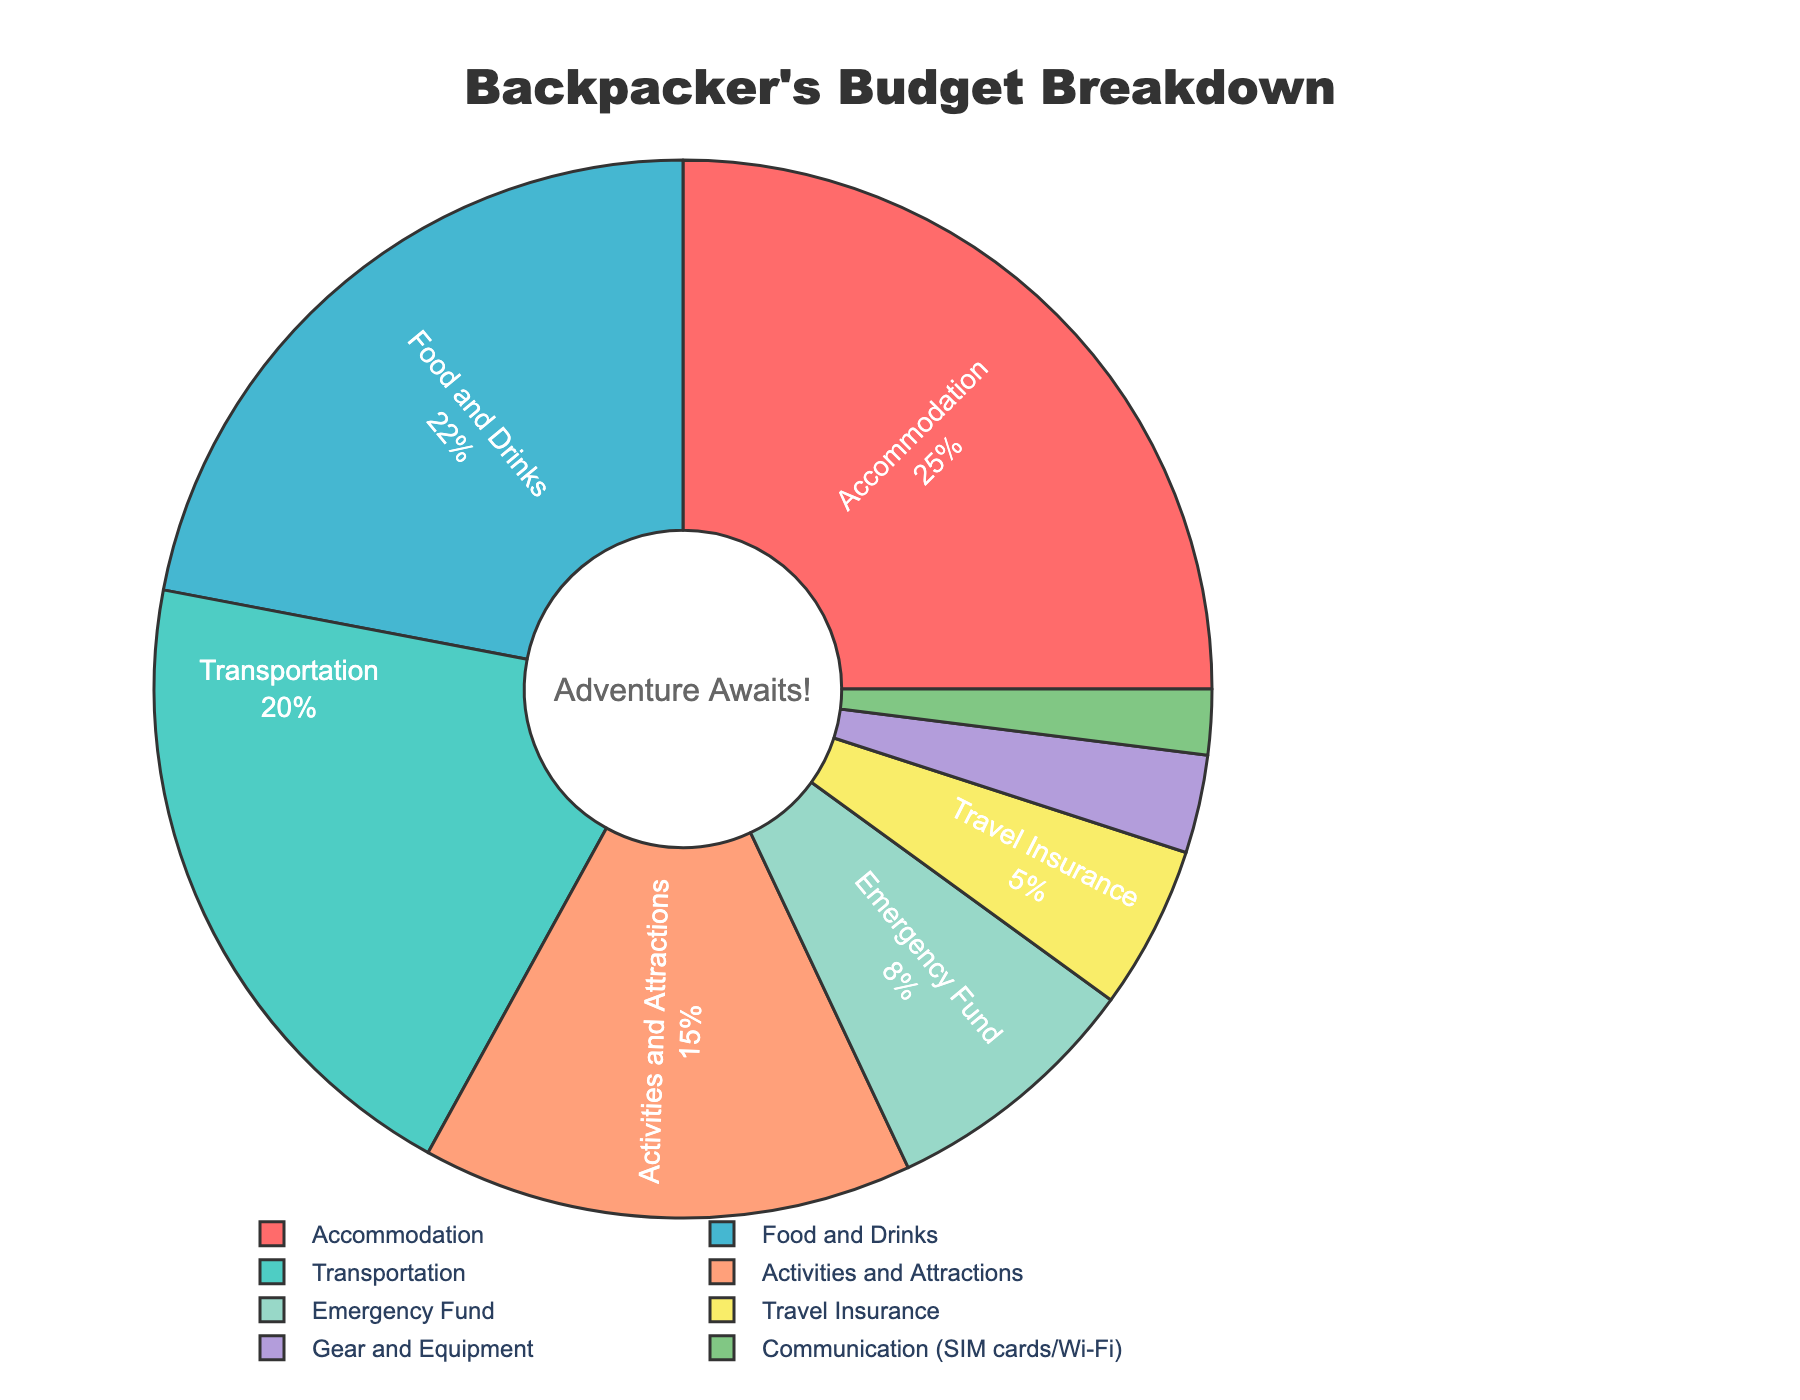What percentage of the budget is allocated for Accommodation and Food and Drinks combined? The percentage for Accommodation is 25% and for Food and Drinks is 22%. Adding these together, 25% + 22% = 47%.
Answer: 47% Which category has a larger allocation, Activities and Attractions or Transportation? The allocation for Activities and Attractions is 15% and for Transportation is 20%. 20% is larger than 15%.
Answer: Transportation What is the difference in budget allocation between the highest and lowest expense categories? The highest allocation is Accommodation at 25% and the lowest is Communication at 2%. The difference is 25% - 2% = 23%.
Answer: 23% What proportion of the budget is allocated to categories other than Accommodation, Transportation, and Food and Drinks? Adding the percentages of Accommodation (25%), Transportation (20%), and Food and Drinks (22%) gives 67%. Subtracting this from 100% gives 100% - 67% = 33%.
Answer: 33% Which category is represented by the green section of the pie chart? The green section represents Transportation. This can be identified by matching the color of the section to the label in the legend.
Answer: Transportation Is the budget allocation for Emergency Fund greater than that for Gear and Equipment? Emergency Fund is allocated 8% and Gear and Equipment is allocated 3%. 8% is greater than 3%.
Answer: Yes What percentage of the budget is allocated to Emergency Fund and Travel Insurance together? The percentage for Emergency Fund is 8% and for Travel Insurance is 5%. Adding these together gives 8% + 5% = 13%.
Answer: 13% Does the total budget allocation for Food and Drinks and Activities and Attractions equal the budget for Accommodation? Food and Drinks is allocated 22% and Activities and Attractions is 15%. Adding these gives 22% + 15% = 37%. Accommodation is allocated 25%, which is not equal to 37%.
Answer: No 